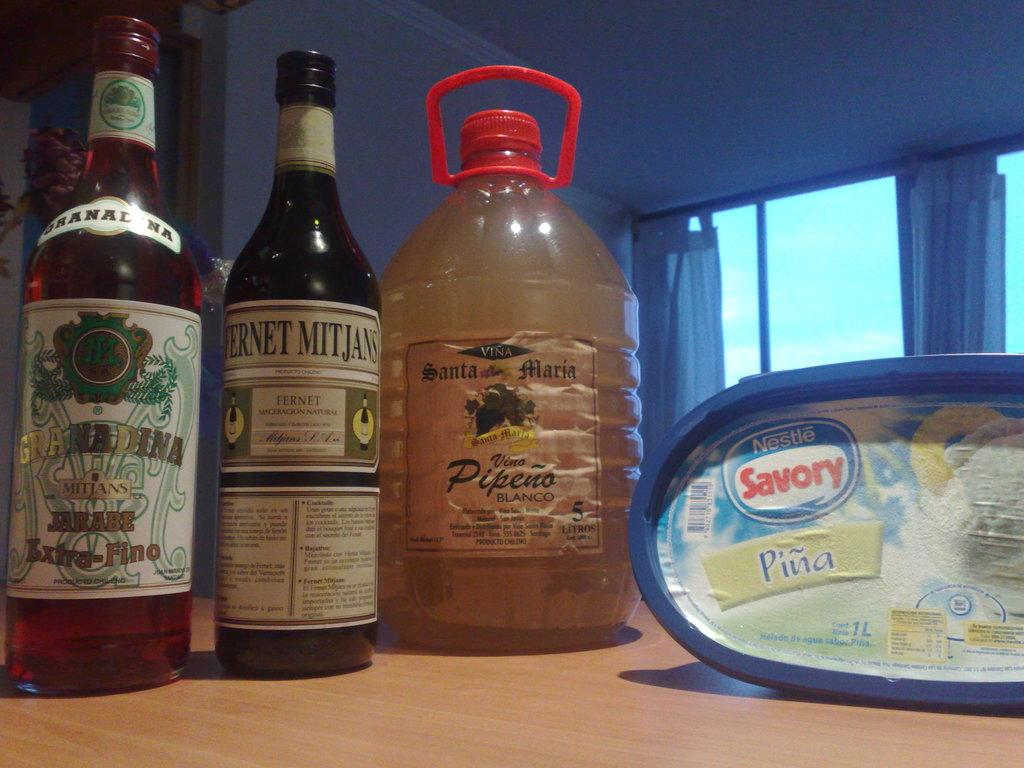What type of furniture is present in the image? There is a table in the image. What items can be seen on the table? There are bottles, a plastic can, and a box on the table. What is visible in the background of the image? There is a window with a curtain and a wall visible in the background. What news is being offered by the crook in the image? There is no crook or news present in the image. 